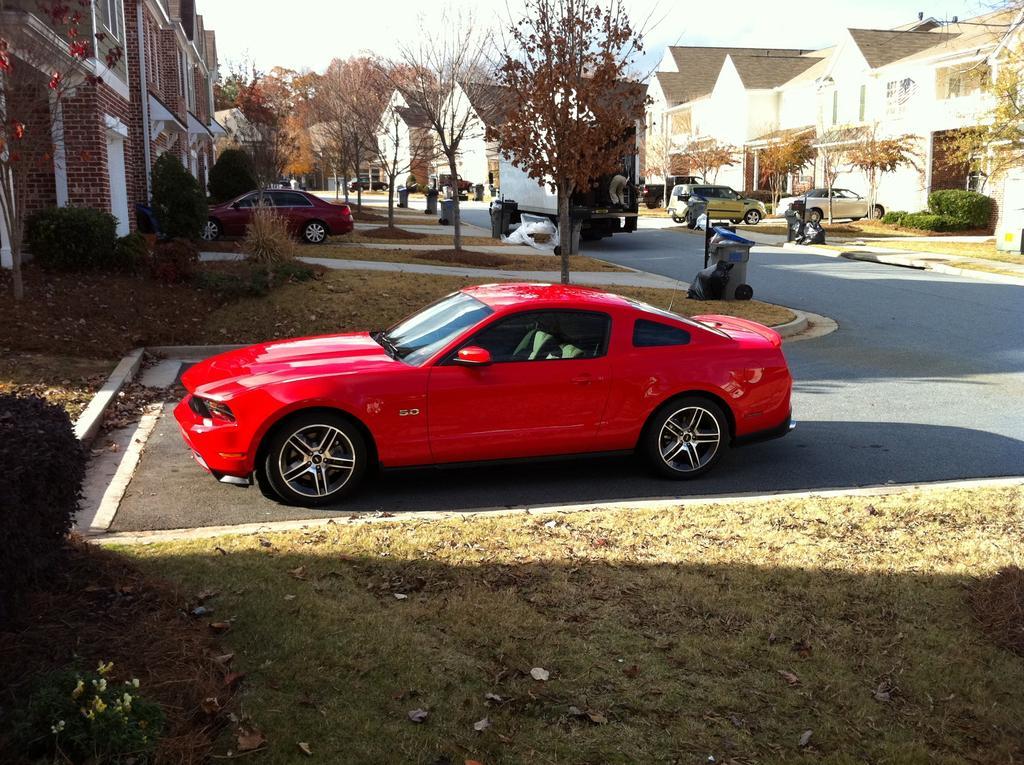How would you summarize this image in a sentence or two? In this image I can see number of cars, a road and number of trees. I can also see number of buildings on the both side of this image. I can also see grass in the front and in the background. 